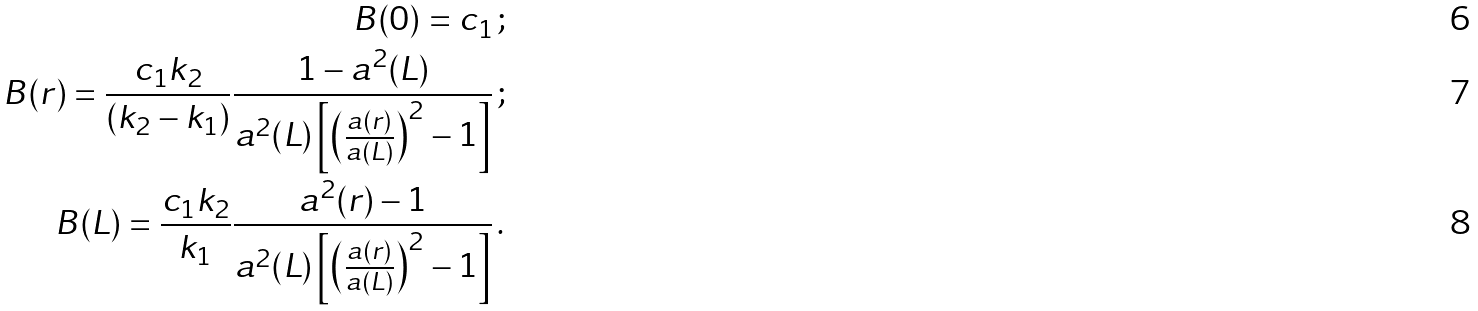Convert formula to latex. <formula><loc_0><loc_0><loc_500><loc_500>B ( 0 ) = c _ { 1 } \, ; \\ B ( r ) = \frac { c _ { 1 } k _ { 2 } } { ( k _ { 2 } - k _ { 1 } ) } \frac { 1 - a ^ { 2 } ( L ) } { a ^ { 2 } ( L ) \left [ \left ( \frac { a ( r ) } { a ( L ) } \right ) ^ { 2 } - 1 \right ] } \, ; \\ B ( L ) = \frac { c _ { 1 } k _ { 2 } } { k _ { 1 } } \frac { a ^ { 2 } ( r ) - 1 } { a ^ { 2 } ( L ) \left [ \left ( \frac { a ( r ) } { a ( L ) } \right ) ^ { 2 } - 1 \right ] } \, .</formula> 